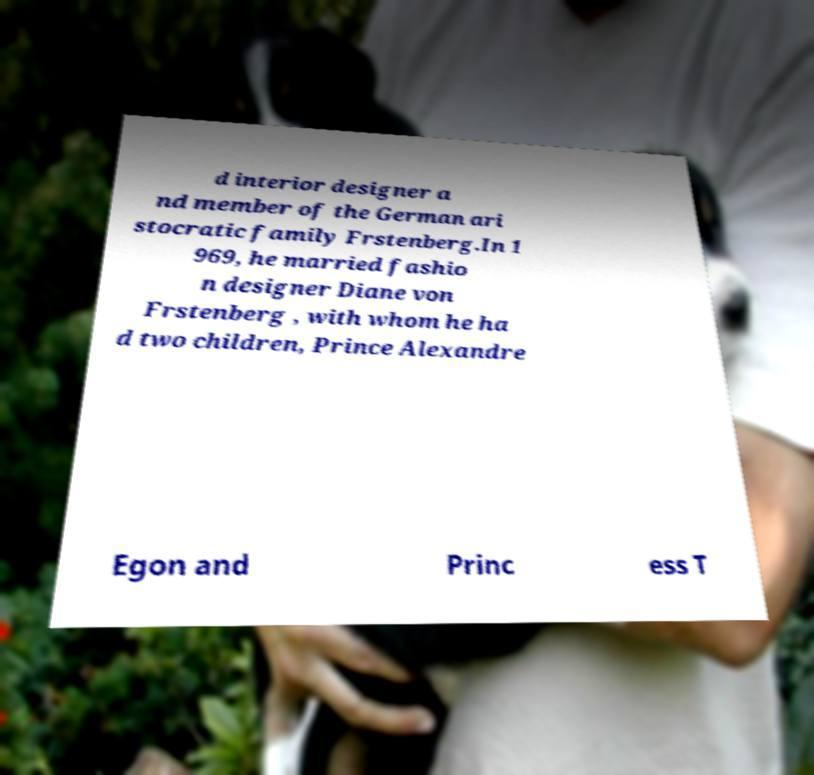Can you accurately transcribe the text from the provided image for me? d interior designer a nd member of the German ari stocratic family Frstenberg.In 1 969, he married fashio n designer Diane von Frstenberg , with whom he ha d two children, Prince Alexandre Egon and Princ ess T 